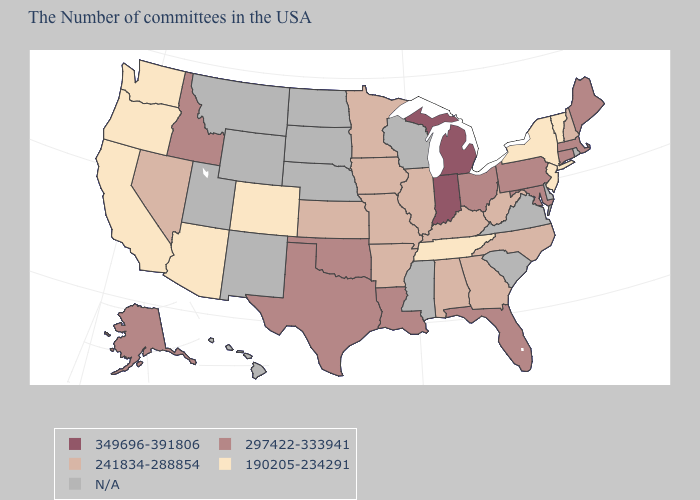Which states have the highest value in the USA?
Keep it brief. Michigan, Indiana. What is the value of Minnesota?
Answer briefly. 241834-288854. What is the value of New Hampshire?
Give a very brief answer. 241834-288854. What is the value of Alaska?
Be succinct. 297422-333941. Does Illinois have the highest value in the MidWest?
Short answer required. No. What is the highest value in the Northeast ?
Keep it brief. 297422-333941. Name the states that have a value in the range 190205-234291?
Keep it brief. Vermont, New York, New Jersey, Tennessee, Colorado, Arizona, California, Washington, Oregon. Name the states that have a value in the range 190205-234291?
Keep it brief. Vermont, New York, New Jersey, Tennessee, Colorado, Arizona, California, Washington, Oregon. Does the map have missing data?
Quick response, please. Yes. What is the value of Arkansas?
Short answer required. 241834-288854. What is the value of Colorado?
Write a very short answer. 190205-234291. Which states have the lowest value in the West?
Quick response, please. Colorado, Arizona, California, Washington, Oregon. Among the states that border Washington , does Idaho have the highest value?
Keep it brief. Yes. What is the value of Idaho?
Concise answer only. 297422-333941. 